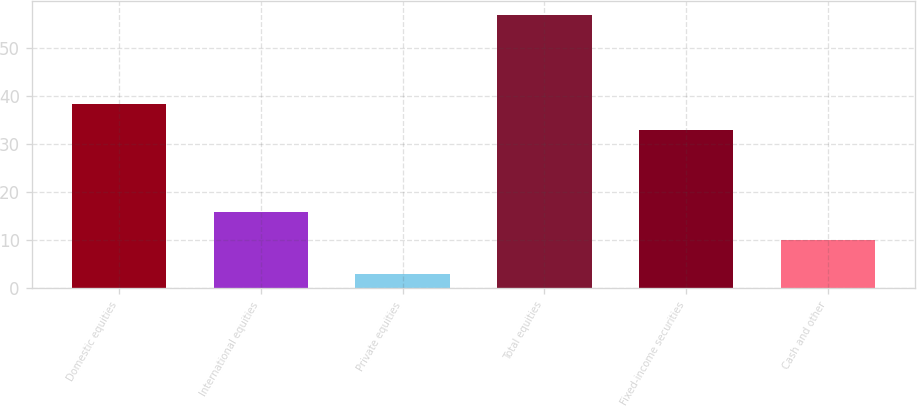<chart> <loc_0><loc_0><loc_500><loc_500><bar_chart><fcel>Domestic equities<fcel>International equities<fcel>Private equities<fcel>Total equities<fcel>Fixed-income securities<fcel>Cash and other<nl><fcel>38.4<fcel>16<fcel>3<fcel>57<fcel>33<fcel>10<nl></chart> 